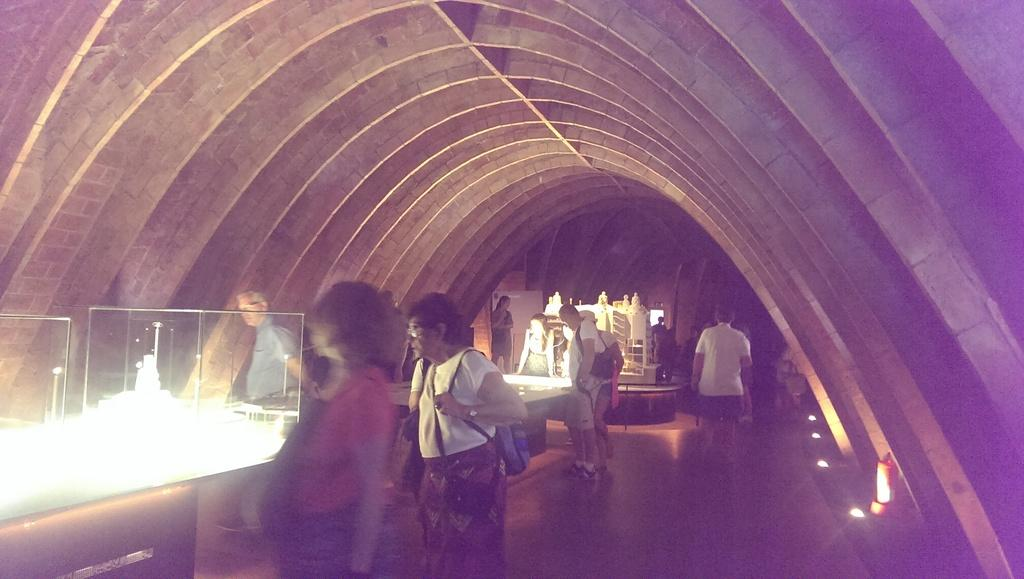What are the people in the image doing? The people in the image are standing and watching. What objects can be seen inside the glass boxes? The glass boxes contain a toy house. What type of lighting is present in the image? There are lights visible in the image. Can you suggest a possible location where the image might have been taken? The image might have been taken in a museum. What month is it in the image? The month cannot be determined from the image, as it does not contain any information about the time of year. Can you describe the head of the person standing closest to the glass box? There is no information about the head or any specific person in the image, as it only shows people standing and watching. 